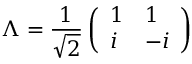Convert formula to latex. <formula><loc_0><loc_0><loc_500><loc_500>\Lambda = \frac { 1 } { \sqrt { 2 } } \left ( \begin{array} { l l } { 1 } & { 1 } \\ { i } & { - i } \end{array} \right )</formula> 